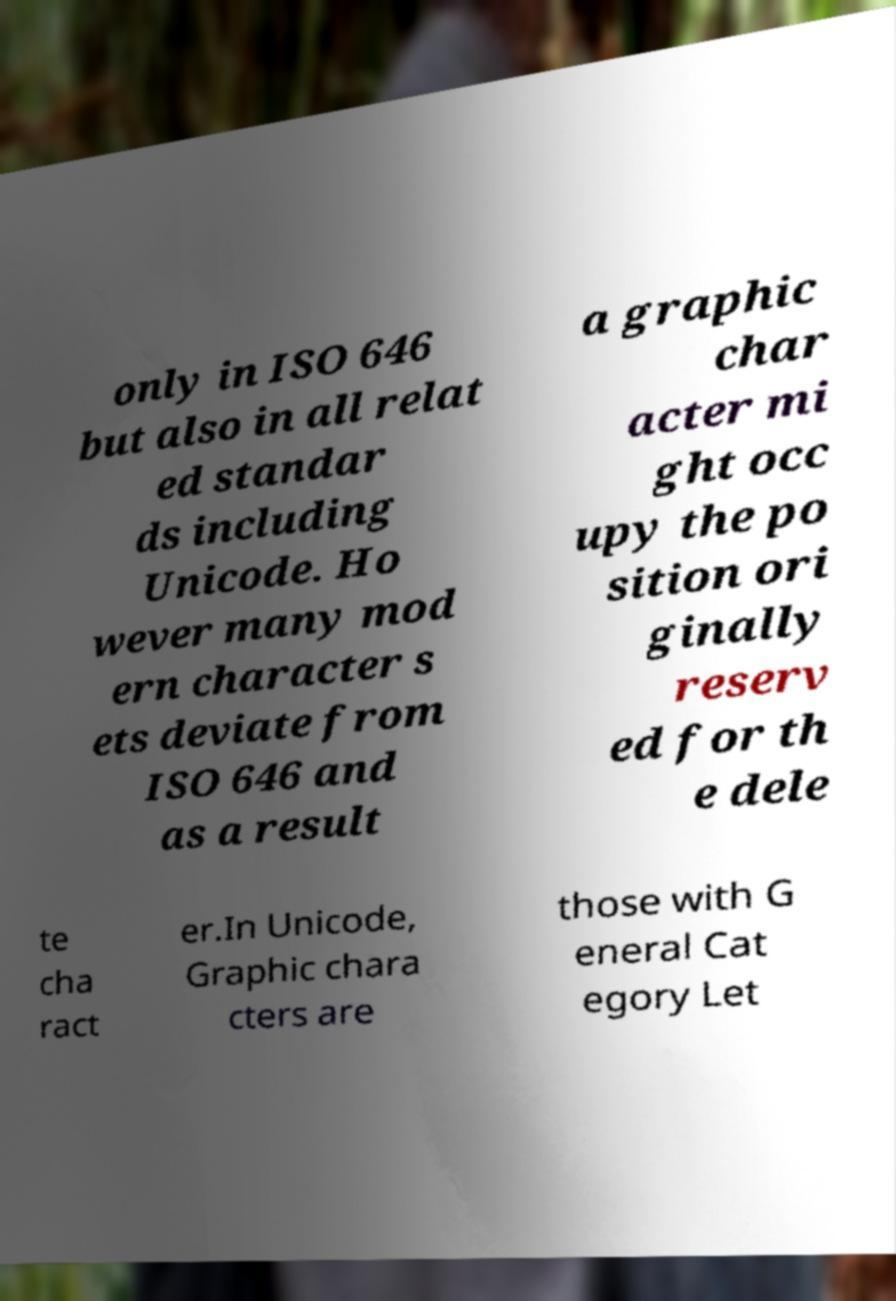I need the written content from this picture converted into text. Can you do that? only in ISO 646 but also in all relat ed standar ds including Unicode. Ho wever many mod ern character s ets deviate from ISO 646 and as a result a graphic char acter mi ght occ upy the po sition ori ginally reserv ed for th e dele te cha ract er.In Unicode, Graphic chara cters are those with G eneral Cat egory Let 